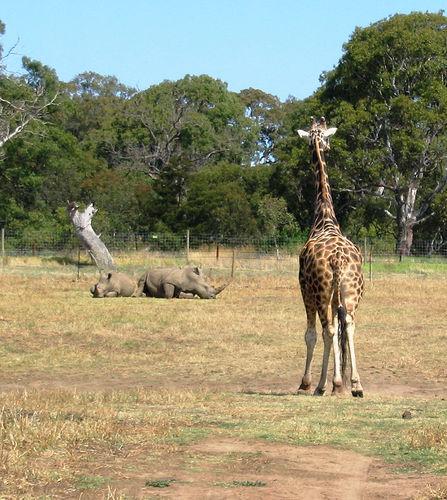Is the giraffe laying down?
Keep it brief. No. How many species are seen?
Write a very short answer. 2. Is the grass mostly green?
Quick response, please. No. 